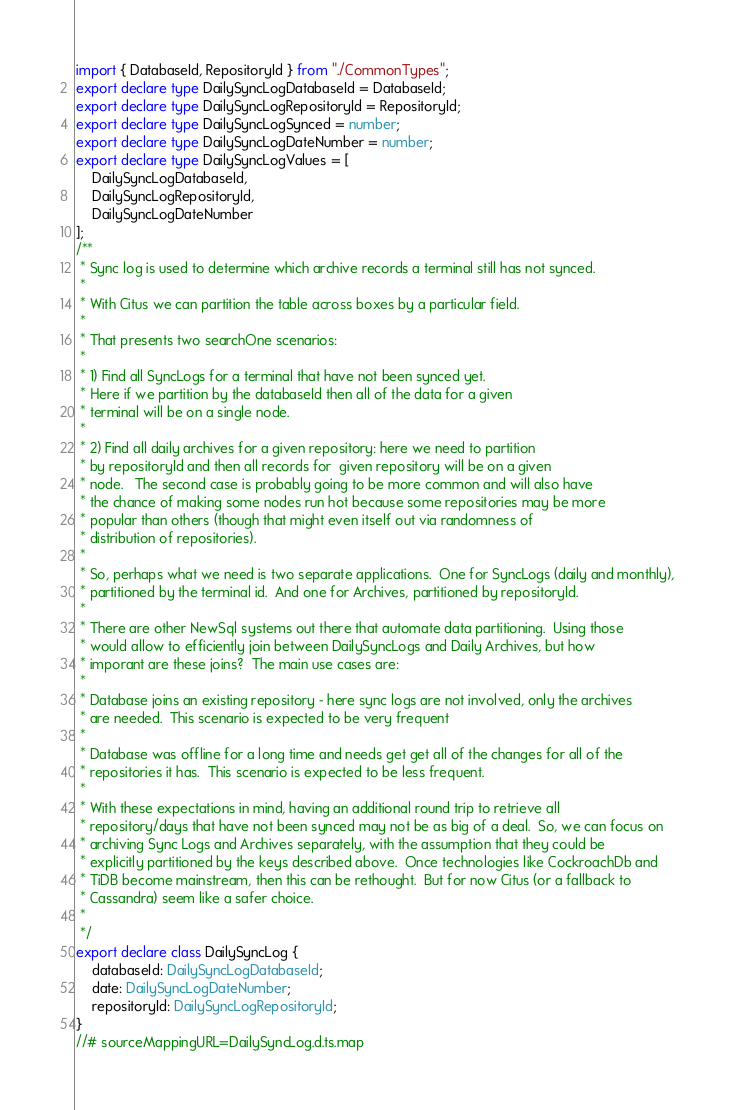<code> <loc_0><loc_0><loc_500><loc_500><_TypeScript_>import { DatabaseId, RepositoryId } from "./CommonTypes";
export declare type DailySyncLogDatabaseId = DatabaseId;
export declare type DailySyncLogRepositoryId = RepositoryId;
export declare type DailySyncLogSynced = number;
export declare type DailySyncLogDateNumber = number;
export declare type DailySyncLogValues = [
    DailySyncLogDatabaseId,
    DailySyncLogRepositoryId,
    DailySyncLogDateNumber
];
/**
 * Sync log is used to determine which archive records a terminal still has not synced.
 *
 * With Citus we can partition the table across boxes by a particular field.
 *
 * That presents two searchOne scenarios:
 *
 * 1) Find all SyncLogs for a terminal that have not been synced yet.
 * Here if we partition by the databaseId then all of the data for a given
 * terminal will be on a single node.
 *
 * 2) Find all daily archives for a given repository: here we need to partition
 * by repositoryId and then all records for  given repository will be on a given
 * node.   The second case is probably going to be more common and will also have
 * the chance of making some nodes run hot because some repositories may be more
 * popular than others (though that might even itself out via randomness of
 * distribution of repositories).
 *
 * So, perhaps what we need is two separate applications.  One for SyncLogs (daily and monthly),
 * partitioned by the terminal id.  And one for Archives, partitioned by repositoryId.
 *
 * There are other NewSql systems out there that automate data partitioning.  Using those
 * would allow to efficiently join between DailySyncLogs and Daily Archives, but how
 * imporant are these joins?  The main use cases are:
 *
 * Database joins an existing repository - here sync logs are not involved, only the archives
 * are needed.  This scenario is expected to be very frequent
 *
 * Database was offline for a long time and needs get get all of the changes for all of the
 * repositories it has.  This scenario is expected to be less frequent.
 *
 * With these expectations in mind, having an additional round trip to retrieve all
 * repository/days that have not been synced may not be as big of a deal.  So, we can focus on
 * archiving Sync Logs and Archives separately, with the assumption that they could be
 * explicitly partitioned by the keys described above.  Once technologies like CockroachDb and
 * TiDB become mainstream, then this can be rethought.  But for now Citus (or a fallback to
 * Cassandra) seem like a safer choice.
 *
 */
export declare class DailySyncLog {
    databaseId: DailySyncLogDatabaseId;
    date: DailySyncLogDateNumber;
    repositoryId: DailySyncLogRepositoryId;
}
//# sourceMappingURL=DailySyncLog.d.ts.map</code> 